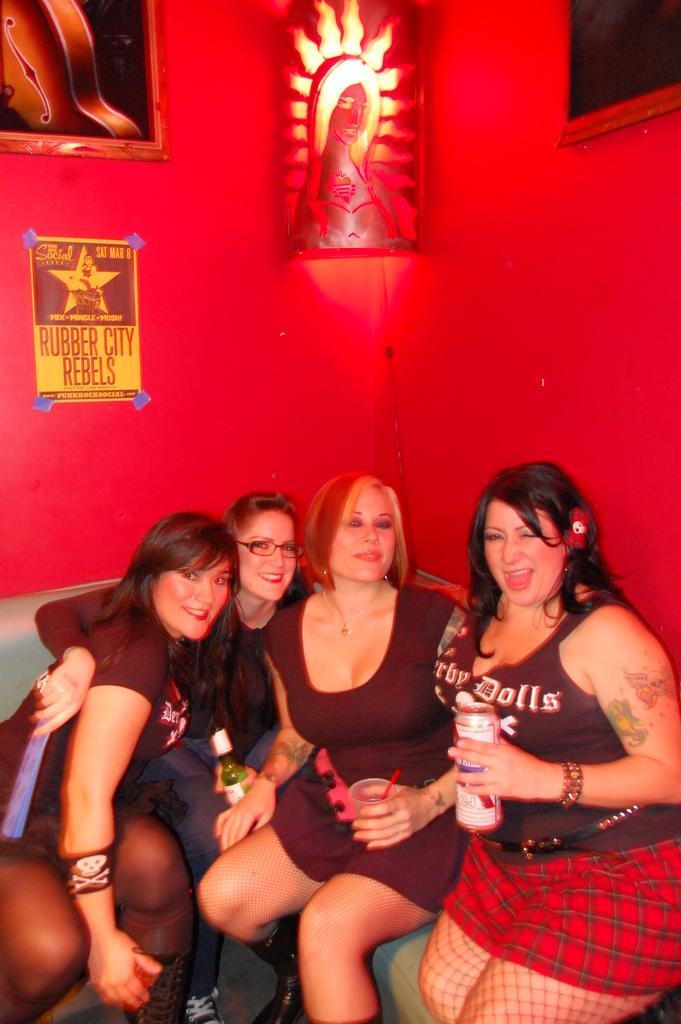How would you summarize this image in a sentence or two? In this image we can see people sitting. The lady sitting on the right is holding a tin. In the background there is a wall and we can see frames placed on the wall. 